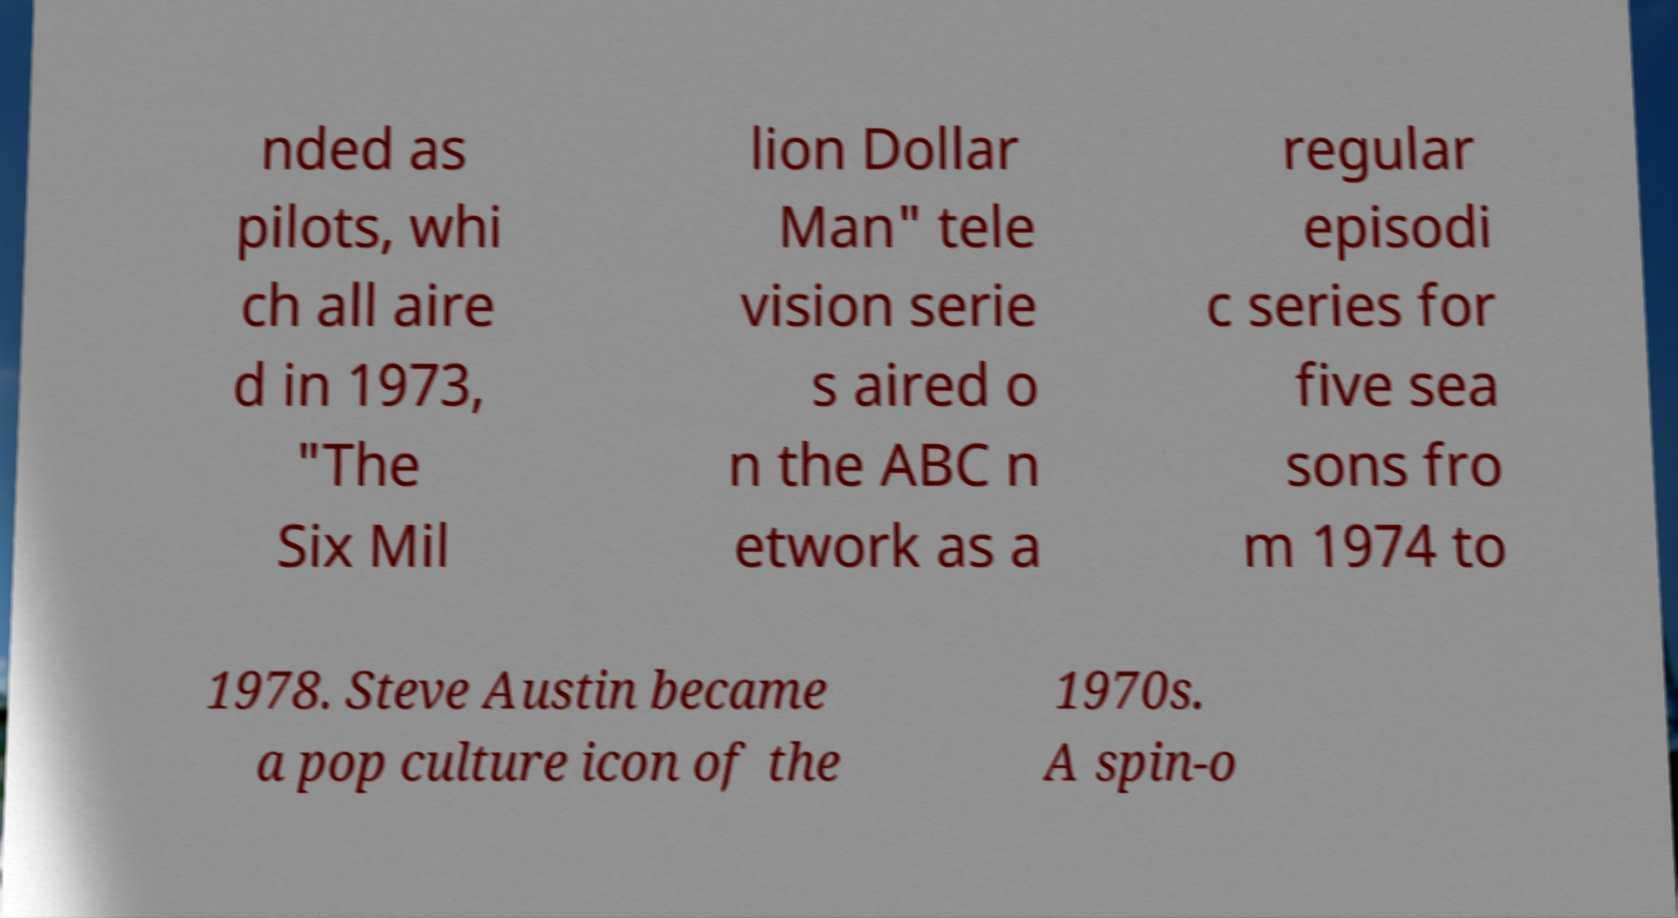Please identify and transcribe the text found in this image. nded as pilots, whi ch all aire d in 1973, "The Six Mil lion Dollar Man" tele vision serie s aired o n the ABC n etwork as a regular episodi c series for five sea sons fro m 1974 to 1978. Steve Austin became a pop culture icon of the 1970s. A spin-o 